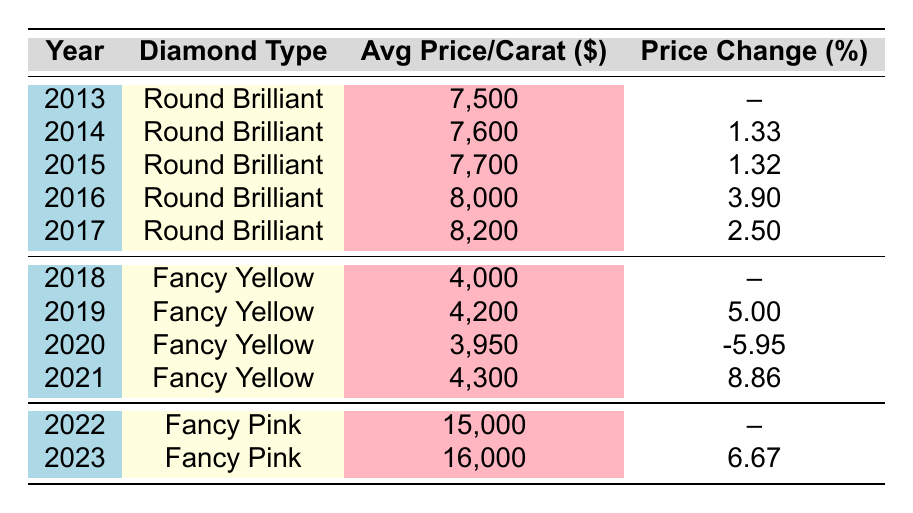What was the average price per carat of Round Brilliant diamonds in 2016? The table indicates that in 2016, the average price per carat of Round Brilliant diamonds was listed as $8,000.
Answer: $8,000 Which diamond type experienced a price increase in 2019? According to the table, the Fancy Yellow diamond type increased in price from $4,000 in 2018 to $4,200 in 2019, showing a price increase of 5.00%.
Answer: Fancy Yellow What is the price change percentage for Fancy Pink diamonds from 2022 to 2023? The table shows that the average price per carat for Fancy Pink diamonds was $15,000 in 2022 and increased to $16,000 in 2023. The price change percentage for this period is calculated as ((16,000 - 15,000) / 15,000) * 100 = 6.67%.
Answer: 6.67% Was the average price per carat of Fancy Yellow diamonds in 2020 lower than in 2019? In the table, the average price for Fancy Yellow diamonds was $4,200 in 2019 and decreased to $3,950 in 2020. This indicates a drop in price, confirming the statement is true.
Answer: Yes What is the total average price per carat for Round Brilliant diamonds from 2013 to 2017? The average prices per carat for Round Brilliant diamonds from 2013 to 2017 are $7,500, $7,600, $7,700, $8,000, and $8,200 respectively. The total sum is calculated as 7,500 + 7,600 + 7,700 + 8,000 + 8,200 = $39,000.
Answer: $39,000 Did the average price per carat for Fancy Yellow diamonds ever exceed $4,300? Looking at the table, the average price for Fancy Yellow diamonds was $4,200 in 2019 and reached $4,300 in 2021, with no values exceeding that threshold in between or after. Therefore, the answer is no.
Answer: No 